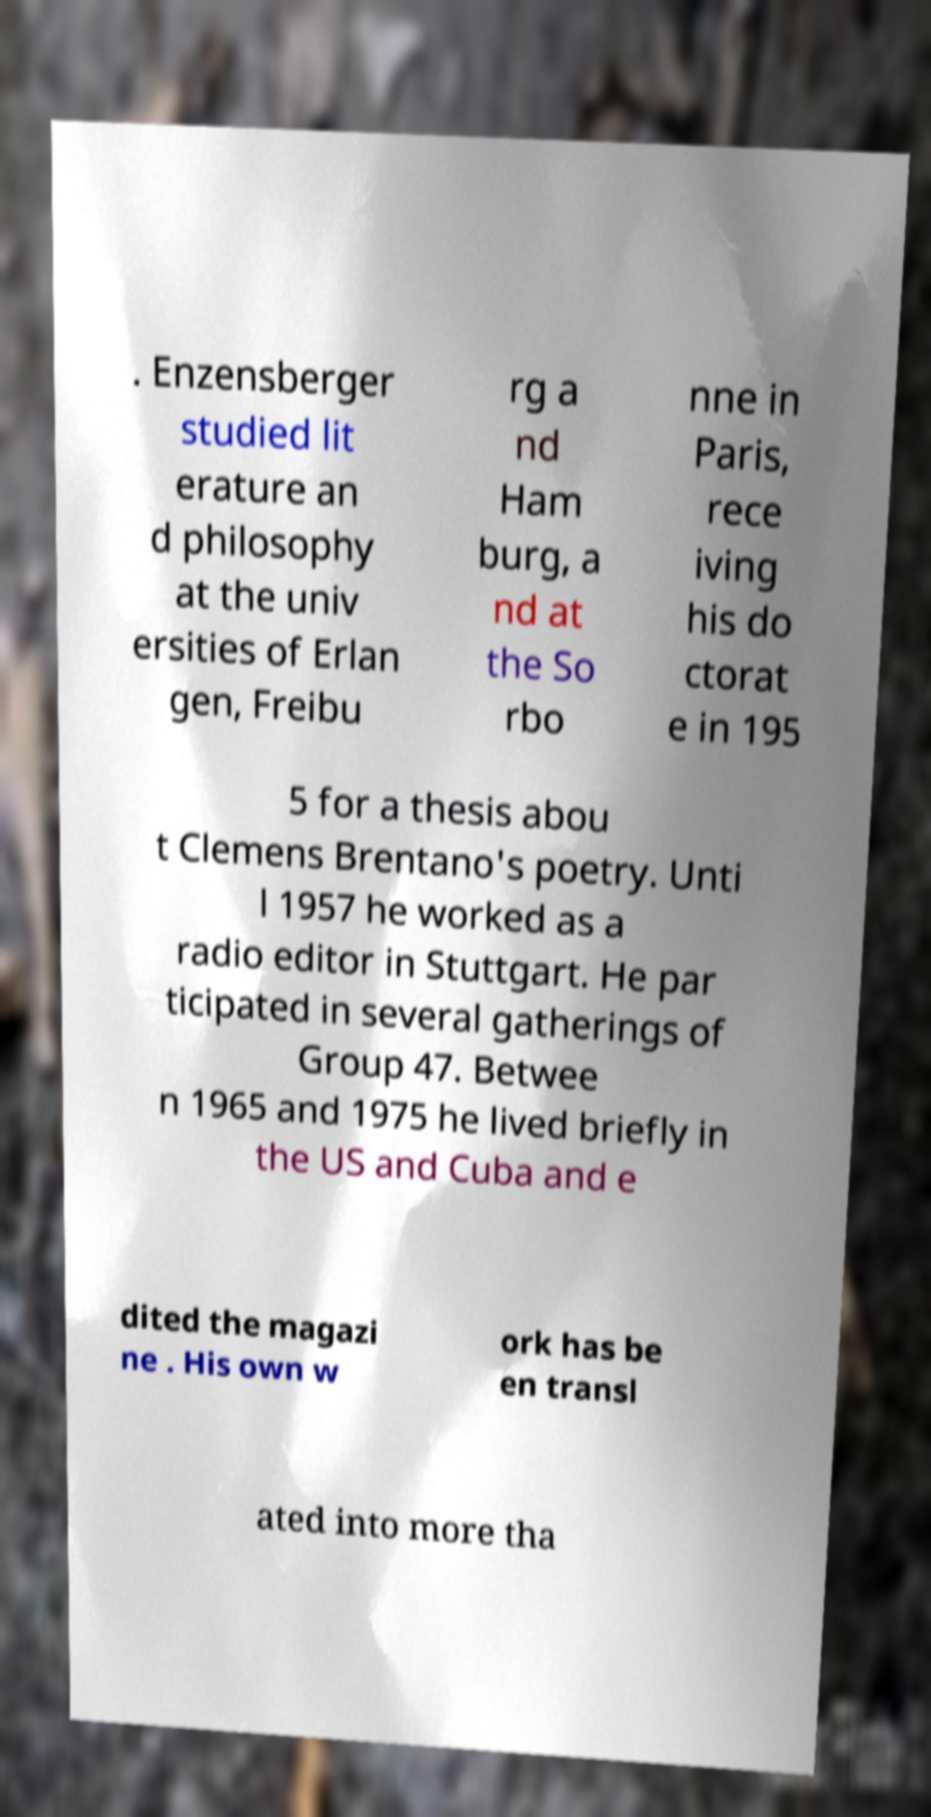Can you accurately transcribe the text from the provided image for me? . Enzensberger studied lit erature an d philosophy at the univ ersities of Erlan gen, Freibu rg a nd Ham burg, a nd at the So rbo nne in Paris, rece iving his do ctorat e in 195 5 for a thesis abou t Clemens Brentano's poetry. Unti l 1957 he worked as a radio editor in Stuttgart. He par ticipated in several gatherings of Group 47. Betwee n 1965 and 1975 he lived briefly in the US and Cuba and e dited the magazi ne . His own w ork has be en transl ated into more tha 